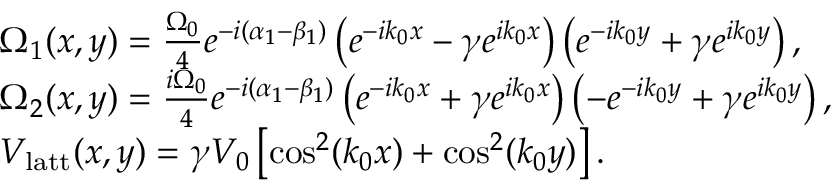Convert formula to latex. <formula><loc_0><loc_0><loc_500><loc_500>\begin{array} { r l } & { \Omega _ { 1 } ( x , y ) = \frac { \Omega _ { 0 } } { 4 } e ^ { - i ( \alpha _ { 1 } - \beta _ { 1 } ) } \left ( e ^ { - i k _ { 0 } x } - \gamma e ^ { i k _ { 0 } x } \right ) \left ( e ^ { - i k _ { 0 } y } + \gamma e ^ { i k _ { 0 } y } \right ) , } \\ & { \Omega _ { 2 } ( x , y ) = \frac { i \Omega _ { 0 } } { 4 } e ^ { - i ( \alpha _ { 1 } - \beta _ { 1 } ) } \left ( e ^ { - i k _ { 0 } x } + \gamma e ^ { i k _ { 0 } x } \right ) \left ( - e ^ { - i k _ { 0 } y } + \gamma e ^ { i k _ { 0 } y } \right ) , } \\ & { V _ { l a t t } ( x , y ) = \gamma V _ { 0 } \left [ \cos ^ { 2 } ( k _ { 0 } x ) + \cos ^ { 2 } ( k _ { 0 } y ) \right ] . } \end{array}</formula> 